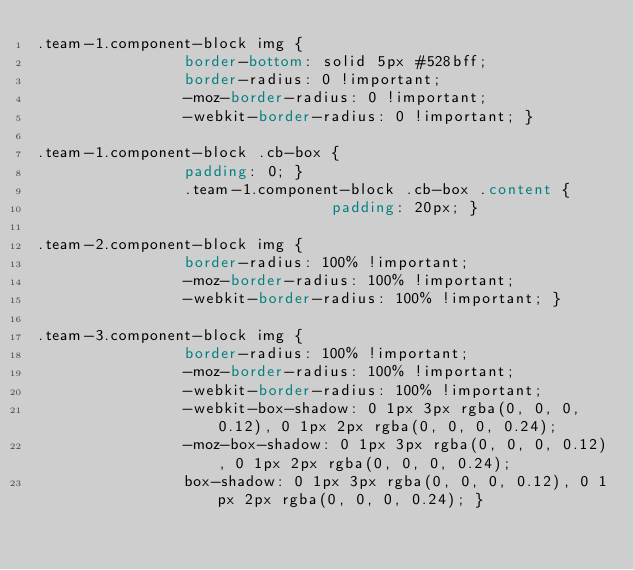Convert code to text. <code><loc_0><loc_0><loc_500><loc_500><_CSS_>.team-1.component-block img {
				border-bottom: solid 5px #528bff;
				border-radius: 0 !important;
				-moz-border-radius: 0 !important;
				-webkit-border-radius: 0 !important; }

.team-1.component-block .cb-box {
				padding: 0; }
				.team-1.component-block .cb-box .content {
								padding: 20px; }

.team-2.component-block img {
				border-radius: 100% !important;
				-moz-border-radius: 100% !important;
				-webkit-border-radius: 100% !important; }

.team-3.component-block img {
				border-radius: 100% !important;
				-moz-border-radius: 100% !important;
				-webkit-border-radius: 100% !important;
				-webkit-box-shadow: 0 1px 3px rgba(0, 0, 0, 0.12), 0 1px 2px rgba(0, 0, 0, 0.24);
				-moz-box-shadow: 0 1px 3px rgba(0, 0, 0, 0.12), 0 1px 2px rgba(0, 0, 0, 0.24);
				box-shadow: 0 1px 3px rgba(0, 0, 0, 0.12), 0 1px 2px rgba(0, 0, 0, 0.24); }
</code> 